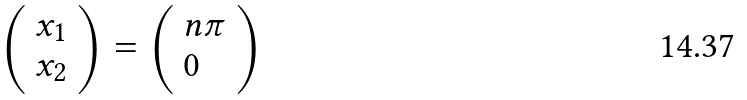<formula> <loc_0><loc_0><loc_500><loc_500>\left ( { \begin{array} { l } { x _ { 1 } } \\ { x _ { 2 } } \end{array} } \right ) = \left ( { \begin{array} { l } { n \pi } \\ { 0 } \end{array} } \right )</formula> 